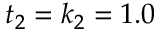<formula> <loc_0><loc_0><loc_500><loc_500>t _ { 2 } = k _ { 2 } = 1 . 0</formula> 